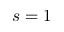Convert formula to latex. <formula><loc_0><loc_0><loc_500><loc_500>s = 1</formula> 